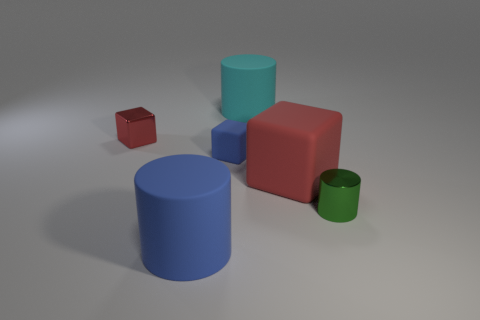Subtract 1 cylinders. How many cylinders are left? 2 Subtract all brown blocks. Subtract all cyan balls. How many blocks are left? 3 Subtract all yellow cylinders. How many cyan cubes are left? 0 Subtract all tiny blue cubes. Subtract all big cyan objects. How many objects are left? 4 Add 1 tiny cubes. How many tiny cubes are left? 3 Add 4 tiny blue rubber cubes. How many tiny blue rubber cubes exist? 5 Add 2 blue cylinders. How many objects exist? 8 Subtract all blue cylinders. How many cylinders are left? 2 Subtract all green metallic cylinders. How many cylinders are left? 2 Subtract 0 gray cylinders. How many objects are left? 6 